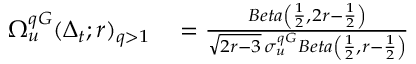<formula> <loc_0><loc_0><loc_500><loc_500>\begin{array} { r l } { \Omega _ { u } ^ { q G } ( \Delta _ { t } ; r ) _ { q > 1 } } & = \frac { B e t a \left ( \frac { 1 } { 2 } , 2 r - \frac { 1 } { 2 } \right ) } { \sqrt { 2 r - 3 } \, \sigma _ { u } ^ { q G } B e t a \left ( \frac { 1 } { 2 } , r - \frac { 1 } { 2 } \right ) } } \end{array}</formula> 